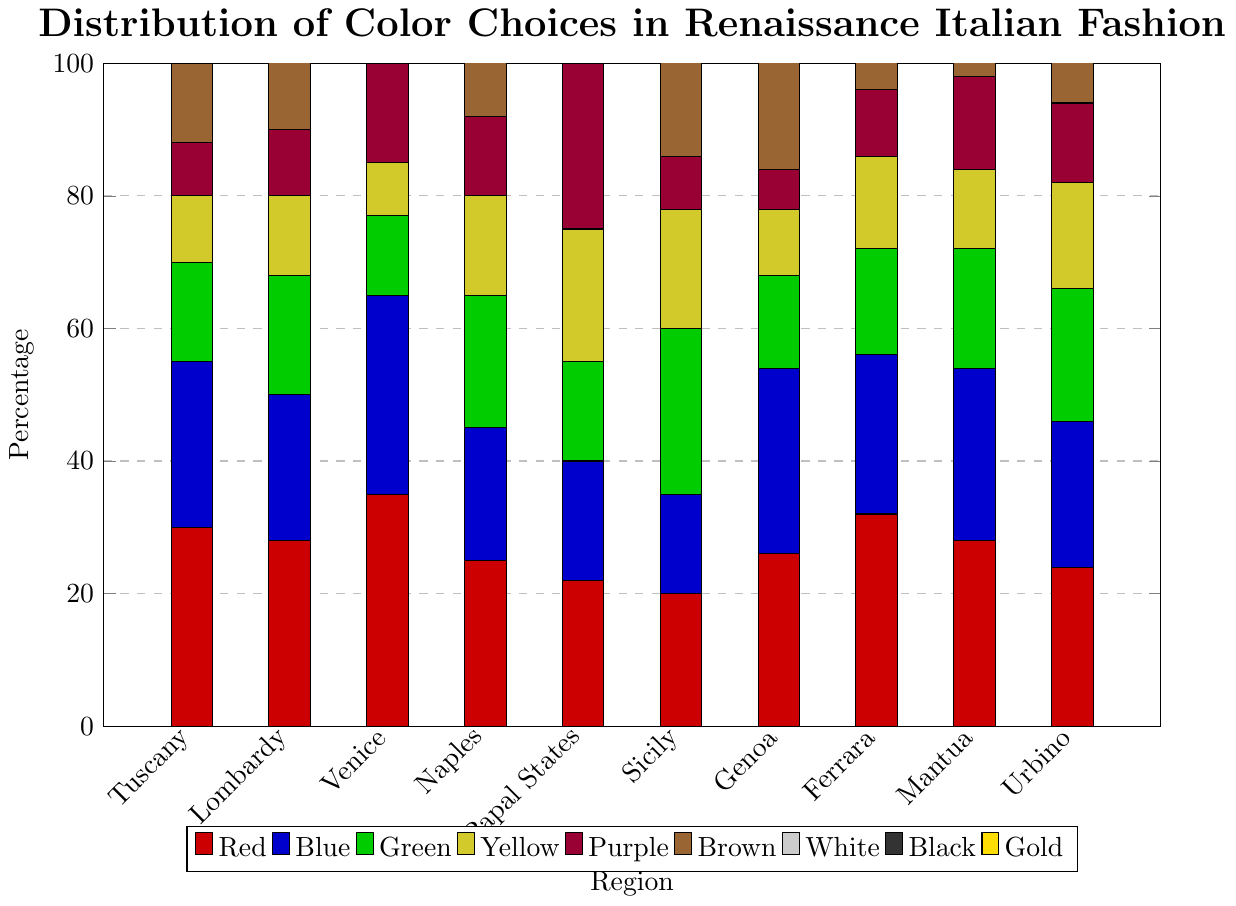What is the most popular color in the Papal States? The Papal States have the highest bar in white, reaching 28, which is higher than any other bar for this region.
Answer: White Which region has the lowest preference for yellow? The yellow bar for Venice is the shortest, standing at 8, which is lower than any other yellow bar for different regions.
Answer: Venice Comparing Tuscany and Venice, which region has a higher overall preference for blue and green combined? Tuscany has blue (25) + green (15) = 40, while Venice has blue (30) + green (12) = 42. Therefore, Venice has a higher combined preference for blue and green.
Answer: Venice How many more people in Naples prefer black compared to gold? The black preference in Naples is 16 and the gold preference is 9. The difference is 16 - 9 = 7.
Answer: 7 What is the average preference for gold across all regions? The gold preferences in each region are 7, 8, 10, 9, 15, 12, 6, 8, 10, 8. Sum these values: 7 + 8 + 10 + 9 + 15 + 12 + 6 + 8 + 10 + 8 = 93. There are 10 regions, so the average is 93 / 10 = 9.3.
Answer: 9.3 Which two regions have the equal highest preference for black? Both Ferrara and Tuscany have the black preference bars reaching 20, which is the highest among all regions.
Answer: Ferrara, Tuscany How does the preference for purple in the Papal States compare to purple in Sicily? The purple preference in the Papal States is 25, while in Sicily it is 8. 25 is greater than 8, so the Papal States have a higher preference for purple.
Answer: Papal States Which region has the highest combined preference for red and white? For each region, sum red and white preferences: Tuscany (30 + 20), Lombardy (28 + 18), Venice (35 + 25), Naples (25 + 22), Papal States (22 + 28), Sicily (20 + 16), Genoa (26 + 24), Ferrara (32 + 22), Mantua (28 + 20), Urbino (24 + 18). The highest sum is Venice with 35 + 25 = 60.
Answer: Venice 